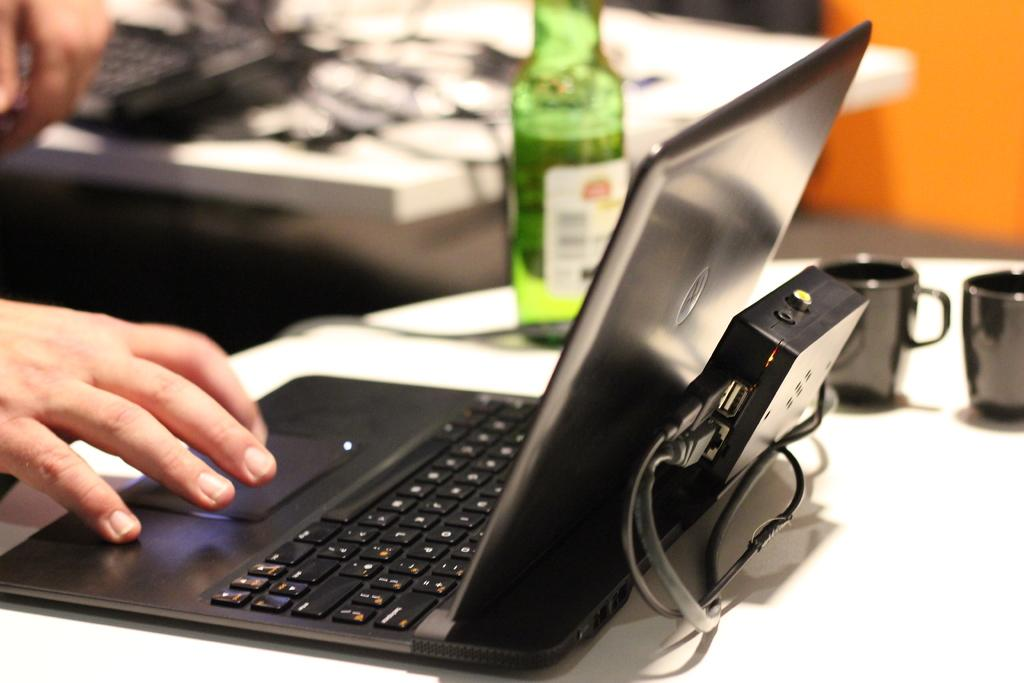What electronic device is visible in the image? There is a laptop in the image. Where is the laptop located? The laptop is on a table. What is placed on top of the laptop in the image? There are bottles on the laptop. Are there any other objects on the laptop? Yes, there are other objects on the laptop. Can you tell me how many people are talking on the laptop in the image? There are no people talking on the laptop in the image; it is a device and does not have the ability to engage in conversation. 